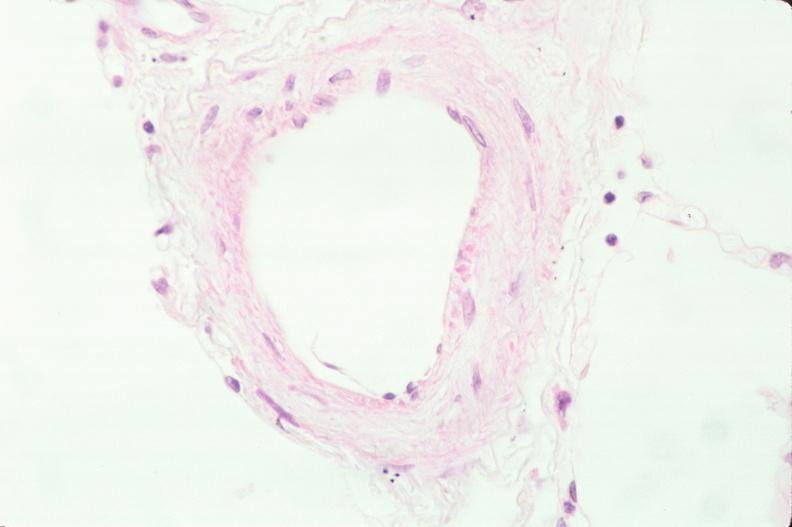what is present?
Answer the question using a single word or phrase. Respiratory 